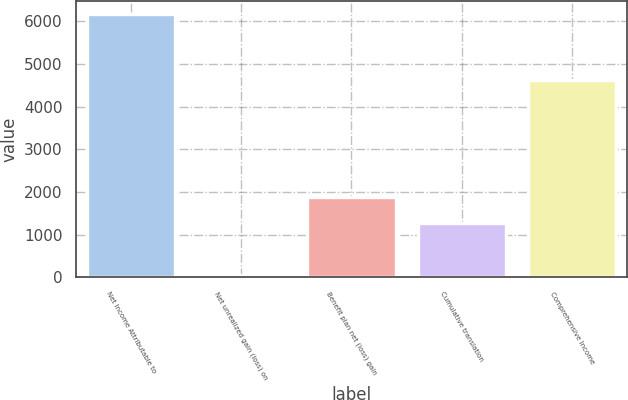Convert chart to OTSL. <chart><loc_0><loc_0><loc_500><loc_500><bar_chart><fcel>Net Income Attributable to<fcel>Net unrealized gain (loss) on<fcel>Benefit plan net (loss) gain<fcel>Cumulative translation<fcel>Comprehensive Income<nl><fcel>6168<fcel>52<fcel>1886.8<fcel>1275.2<fcel>4618<nl></chart> 